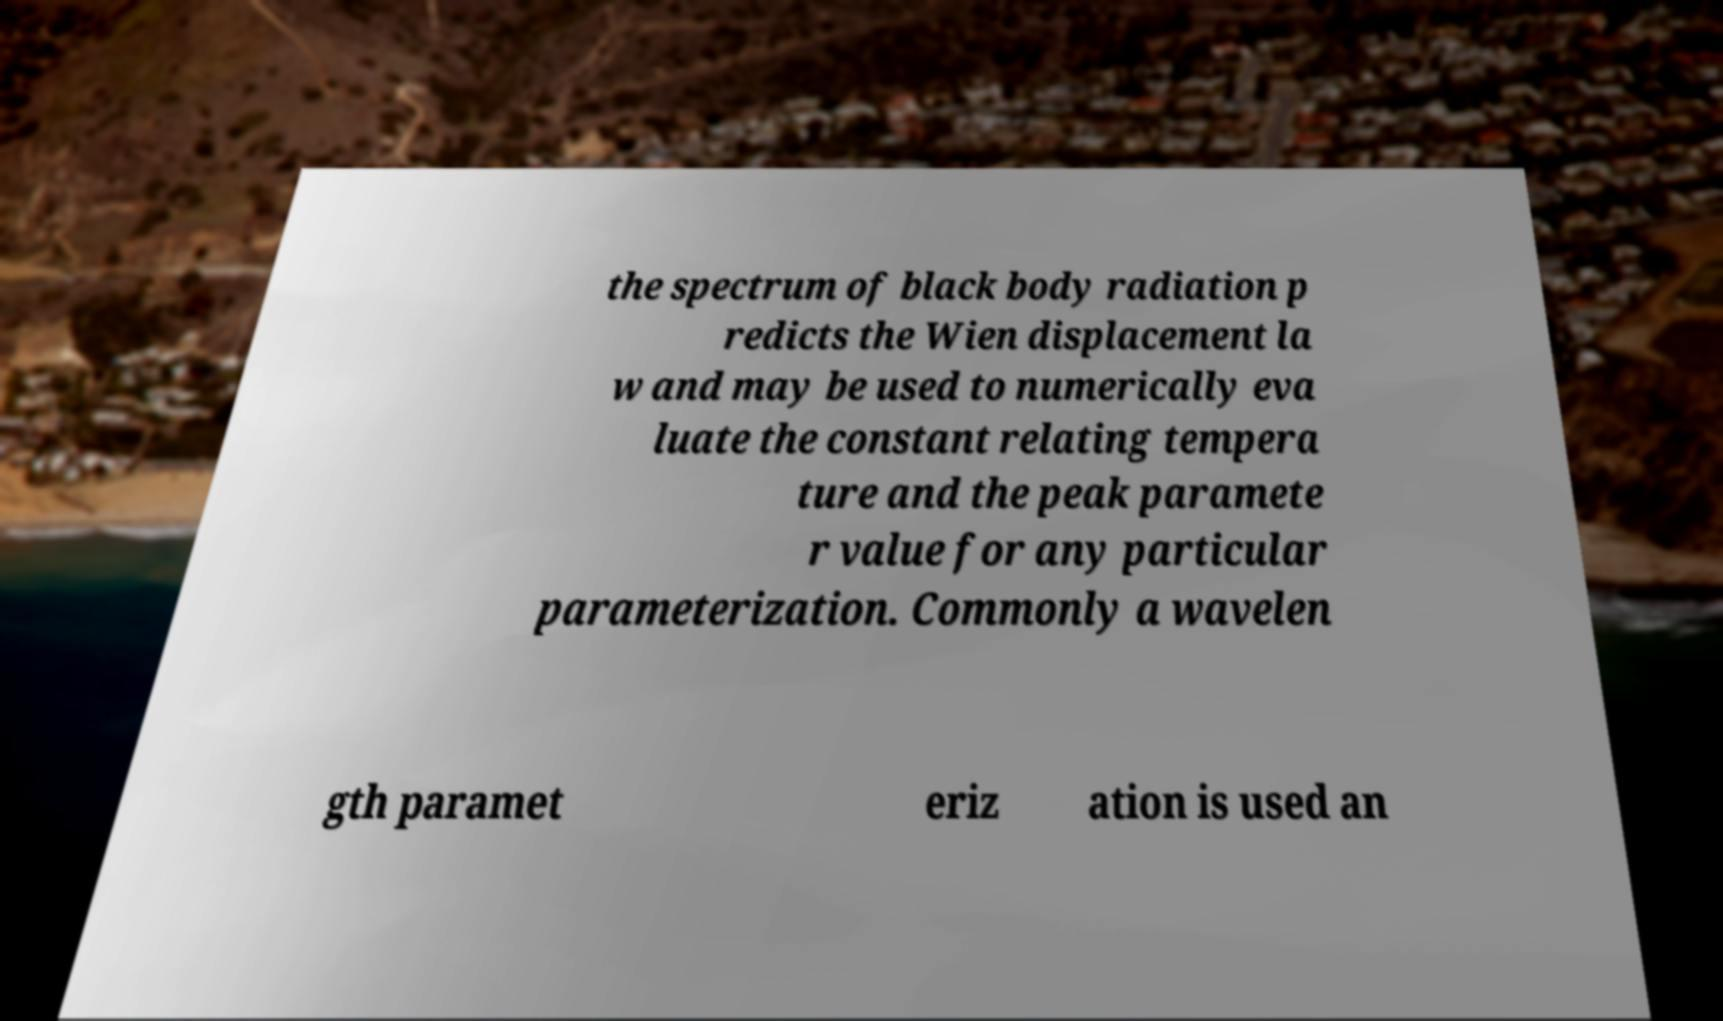Please identify and transcribe the text found in this image. the spectrum of black body radiation p redicts the Wien displacement la w and may be used to numerically eva luate the constant relating tempera ture and the peak paramete r value for any particular parameterization. Commonly a wavelen gth paramet eriz ation is used an 